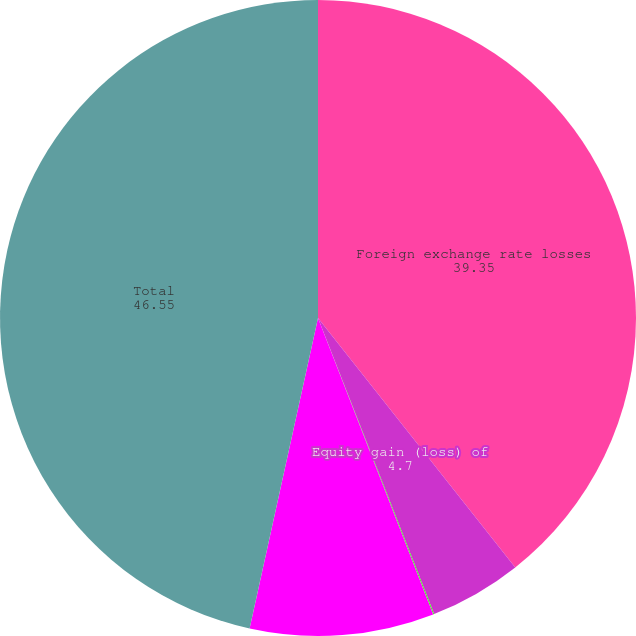<chart> <loc_0><loc_0><loc_500><loc_500><pie_chart><fcel>Foreign exchange rate losses<fcel>Equity gain (loss) of<fcel>Gain (loss) on derivative<fcel>Other<fcel>Total<nl><fcel>39.35%<fcel>4.7%<fcel>0.05%<fcel>9.35%<fcel>46.55%<nl></chart> 